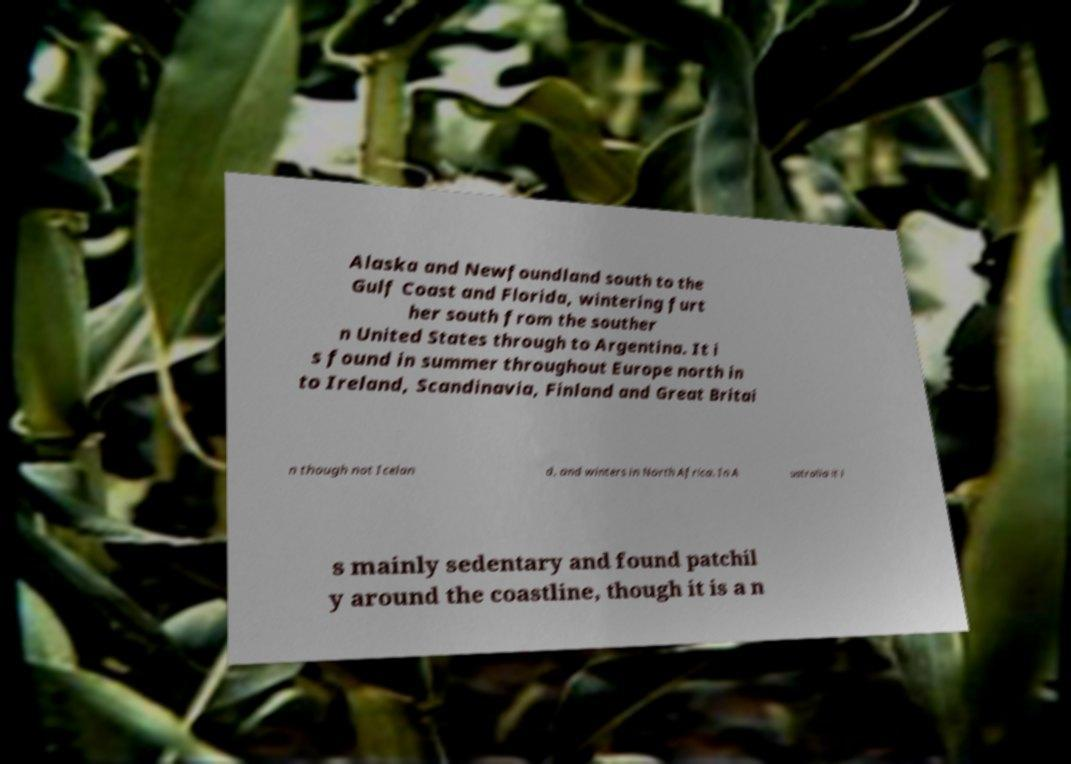Please read and relay the text visible in this image. What does it say? Alaska and Newfoundland south to the Gulf Coast and Florida, wintering furt her south from the souther n United States through to Argentina. It i s found in summer throughout Europe north in to Ireland, Scandinavia, Finland and Great Britai n though not Icelan d, and winters in North Africa. In A ustralia it i s mainly sedentary and found patchil y around the coastline, though it is a n 